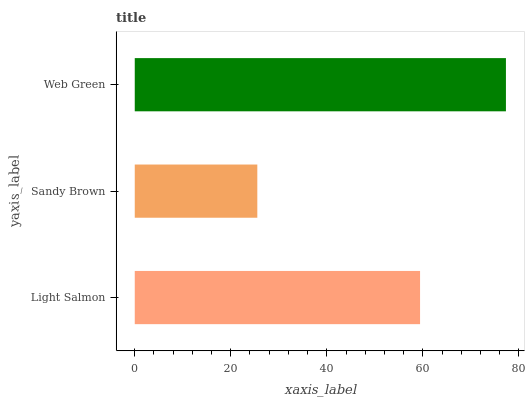Is Sandy Brown the minimum?
Answer yes or no. Yes. Is Web Green the maximum?
Answer yes or no. Yes. Is Web Green the minimum?
Answer yes or no. No. Is Sandy Brown the maximum?
Answer yes or no. No. Is Web Green greater than Sandy Brown?
Answer yes or no. Yes. Is Sandy Brown less than Web Green?
Answer yes or no. Yes. Is Sandy Brown greater than Web Green?
Answer yes or no. No. Is Web Green less than Sandy Brown?
Answer yes or no. No. Is Light Salmon the high median?
Answer yes or no. Yes. Is Light Salmon the low median?
Answer yes or no. Yes. Is Web Green the high median?
Answer yes or no. No. Is Sandy Brown the low median?
Answer yes or no. No. 